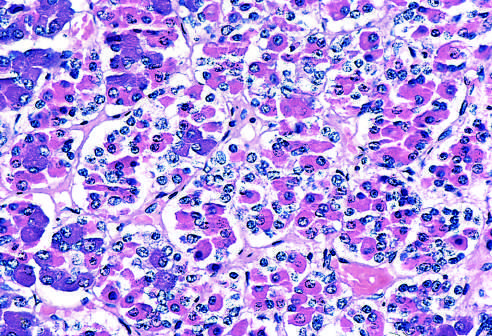s nuclear pleomorphism populated by several distinct cell types that express different peptide hormones?
Answer the question using a single word or phrase. No 